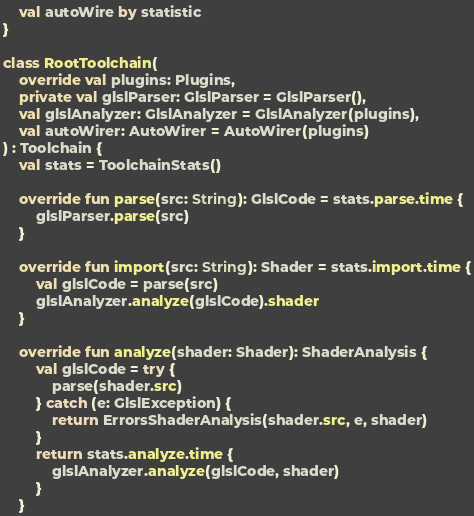Convert code to text. <code><loc_0><loc_0><loc_500><loc_500><_Kotlin_>    val autoWire by statistic
}

class RootToolchain(
    override val plugins: Plugins,
    private val glslParser: GlslParser = GlslParser(),
    val glslAnalyzer: GlslAnalyzer = GlslAnalyzer(plugins),
    val autoWirer: AutoWirer = AutoWirer(plugins)
) : Toolchain {
    val stats = ToolchainStats()

    override fun parse(src: String): GlslCode = stats.parse.time {
        glslParser.parse(src)
    }

    override fun import(src: String): Shader = stats.import.time {
        val glslCode = parse(src)
        glslAnalyzer.analyze(glslCode).shader
    }

    override fun analyze(shader: Shader): ShaderAnalysis {
        val glslCode = try {
            parse(shader.src)
        } catch (e: GlslException) {
            return ErrorsShaderAnalysis(shader.src, e, shader)
        }
        return stats.analyze.time {
            glslAnalyzer.analyze(glslCode, shader)
        }
    }
</code> 